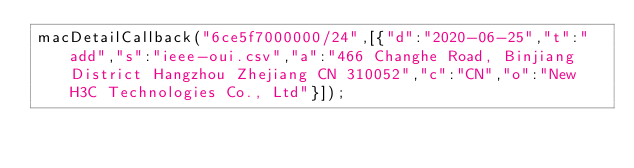<code> <loc_0><loc_0><loc_500><loc_500><_JavaScript_>macDetailCallback("6ce5f7000000/24",[{"d":"2020-06-25","t":"add","s":"ieee-oui.csv","a":"466 Changhe Road, Binjiang District Hangzhou Zhejiang CN 310052","c":"CN","o":"New H3C Technologies Co., Ltd"}]);
</code> 